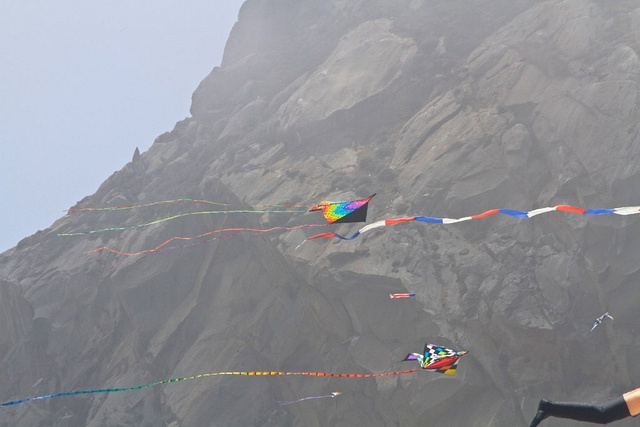Describe the objects in this image and their specific colors. I can see kite in lavender, gray, white, and salmon tones, kite in lavender, gray, brown, darkgray, and teal tones, kite in lavender, black, purple, lightblue, and tan tones, kite in lavender, gray, darkgray, and lightgray tones, and kite in lavender and gray tones in this image. 